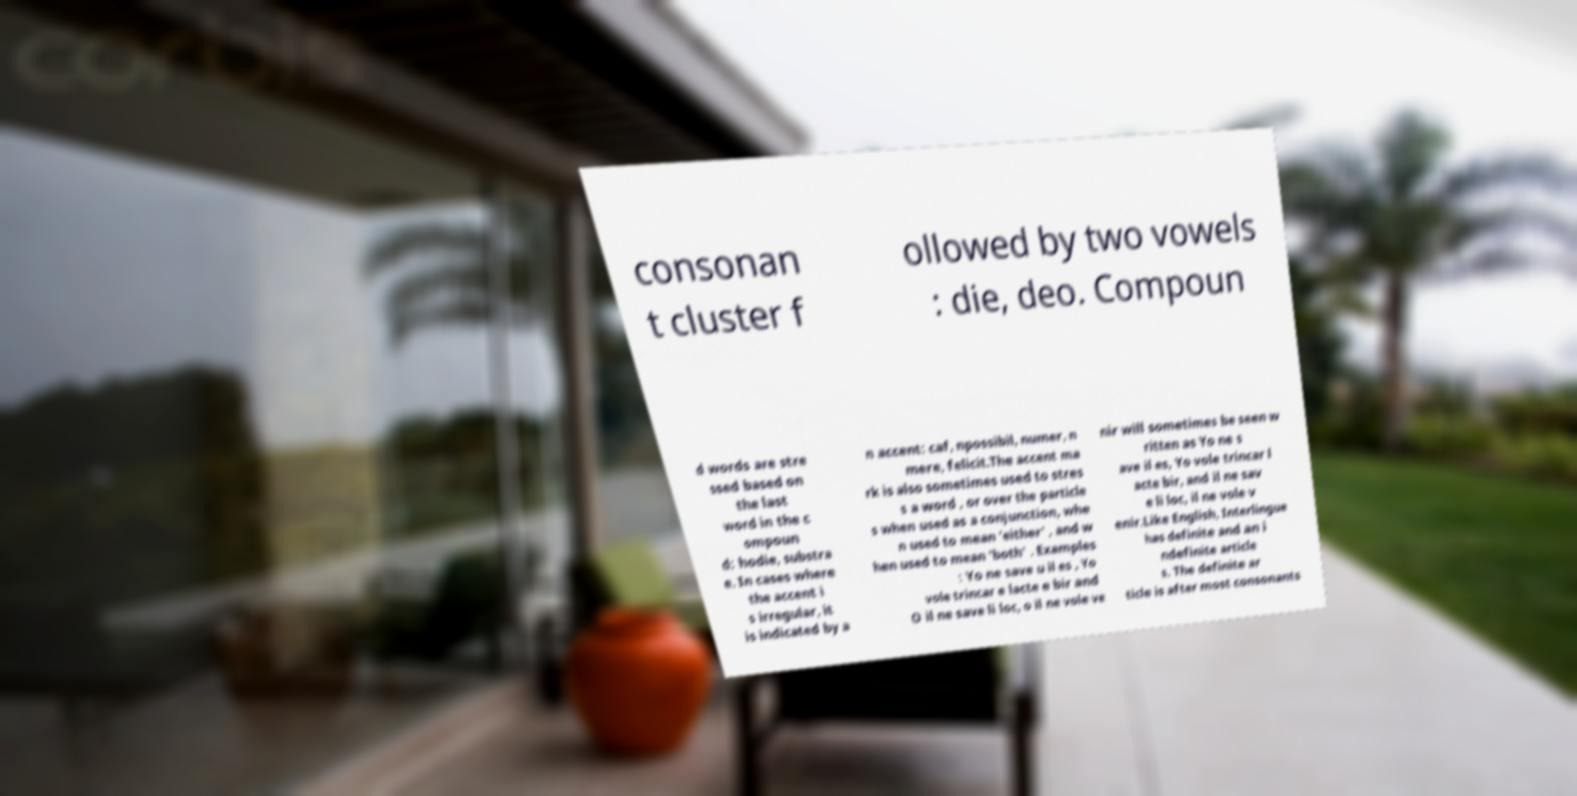Please read and relay the text visible in this image. What does it say? consonan t cluster f ollowed by two vowels : die, deo. Compoun d words are stre ssed based on the last word in the c ompoun d: hodie, substra e. In cases where the accent i s irregular, it is indicated by a n accent: caf, npossibil, numer, n mere, felicit.The accent ma rk is also sometimes used to stres s a word , or over the particle s when used as a conjunction, whe n used to mean 'either' , and w hen used to mean 'both' . Examples : Yo ne save u il es , Yo vole trincar e lacte e bir and O il ne save li loc, o il ne vole ve nir will sometimes be seen w ritten as Yo ne s ave il es, Yo vole trincar l acte bir, and il ne sav e li loc, il ne vole v enir.Like English, Interlingue has definite and an i ndefinite article s. The definite ar ticle is after most consonants 